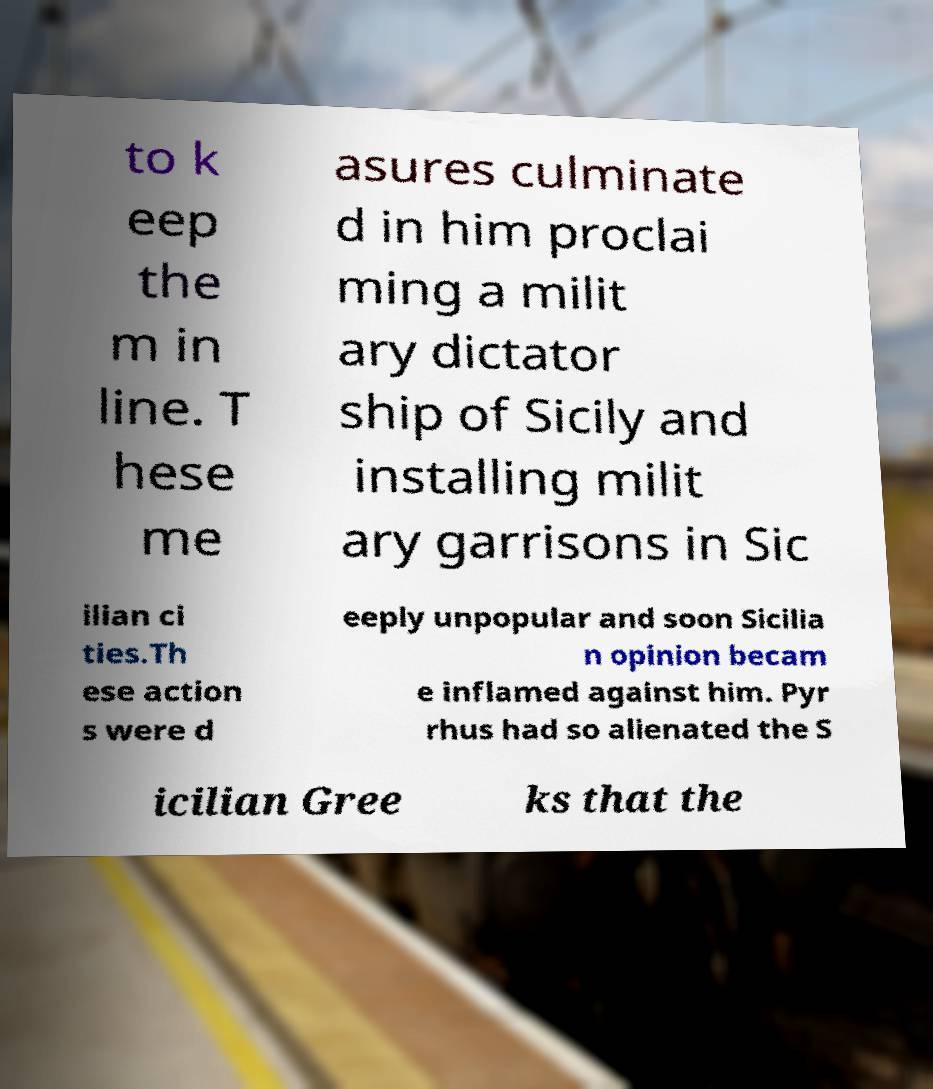Please identify and transcribe the text found in this image. to k eep the m in line. T hese me asures culminate d in him proclai ming a milit ary dictator ship of Sicily and installing milit ary garrisons in Sic ilian ci ties.Th ese action s were d eeply unpopular and soon Sicilia n opinion becam e inflamed against him. Pyr rhus had so alienated the S icilian Gree ks that the 